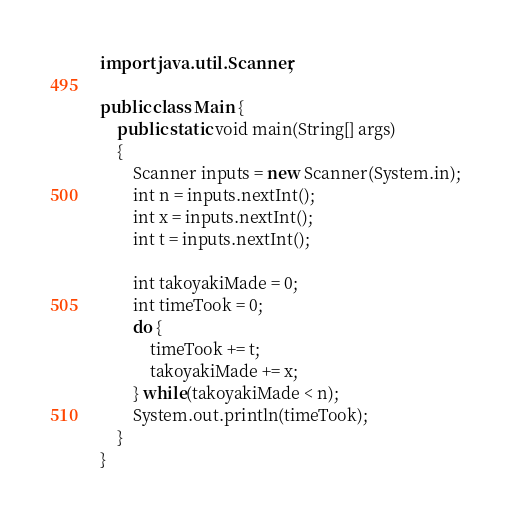<code> <loc_0><loc_0><loc_500><loc_500><_Java_>import java.util.Scanner;

public class Main {
    public static void main(String[] args)
    {
        Scanner inputs = new Scanner(System.in);
        int n = inputs.nextInt();
        int x = inputs.nextInt();
        int t = inputs.nextInt();

        int takoyakiMade = 0;
        int timeTook = 0;
        do {
            timeTook += t;
            takoyakiMade += x;
        } while(takoyakiMade < n);
        System.out.println(timeTook);
    }
}
</code> 